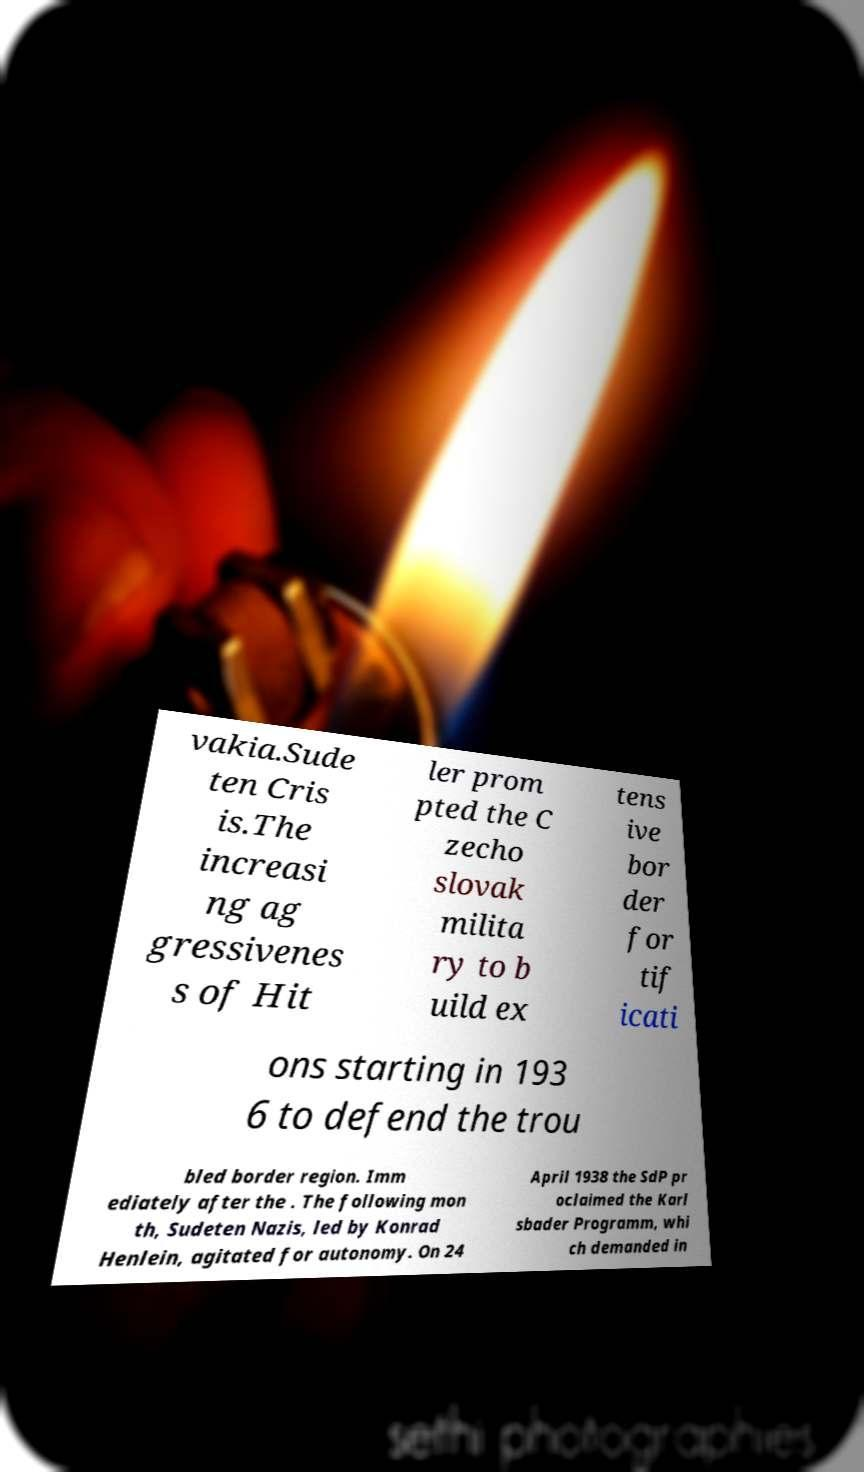I need the written content from this picture converted into text. Can you do that? vakia.Sude ten Cris is.The increasi ng ag gressivenes s of Hit ler prom pted the C zecho slovak milita ry to b uild ex tens ive bor der for tif icati ons starting in 193 6 to defend the trou bled border region. Imm ediately after the . The following mon th, Sudeten Nazis, led by Konrad Henlein, agitated for autonomy. On 24 April 1938 the SdP pr oclaimed the Karl sbader Programm, whi ch demanded in 